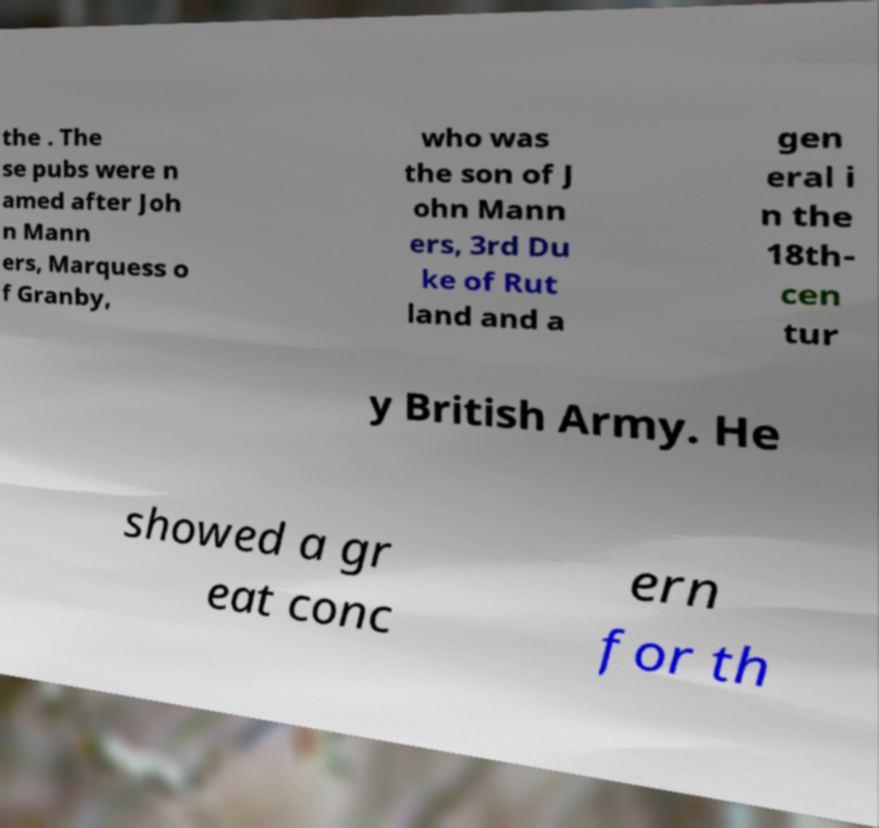Please identify and transcribe the text found in this image. the . The se pubs were n amed after Joh n Mann ers, Marquess o f Granby, who was the son of J ohn Mann ers, 3rd Du ke of Rut land and a gen eral i n the 18th- cen tur y British Army. He showed a gr eat conc ern for th 